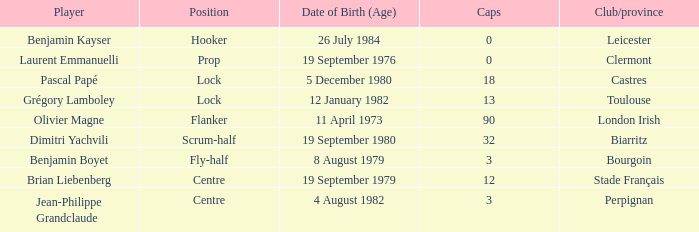Where is perpignan situated? Centre. 